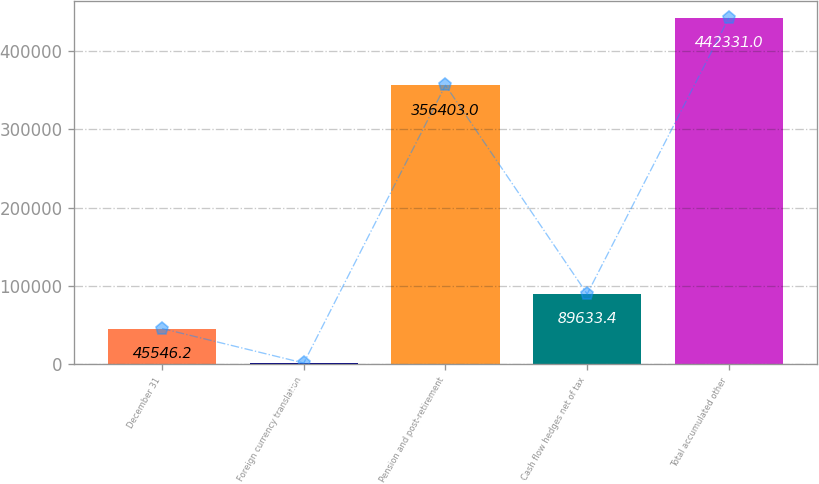Convert chart. <chart><loc_0><loc_0><loc_500><loc_500><bar_chart><fcel>December 31<fcel>Foreign currency translation<fcel>Pension and post-retirement<fcel>Cash flow hedges net of tax<fcel>Total accumulated other<nl><fcel>45546.2<fcel>1459<fcel>356403<fcel>89633.4<fcel>442331<nl></chart> 